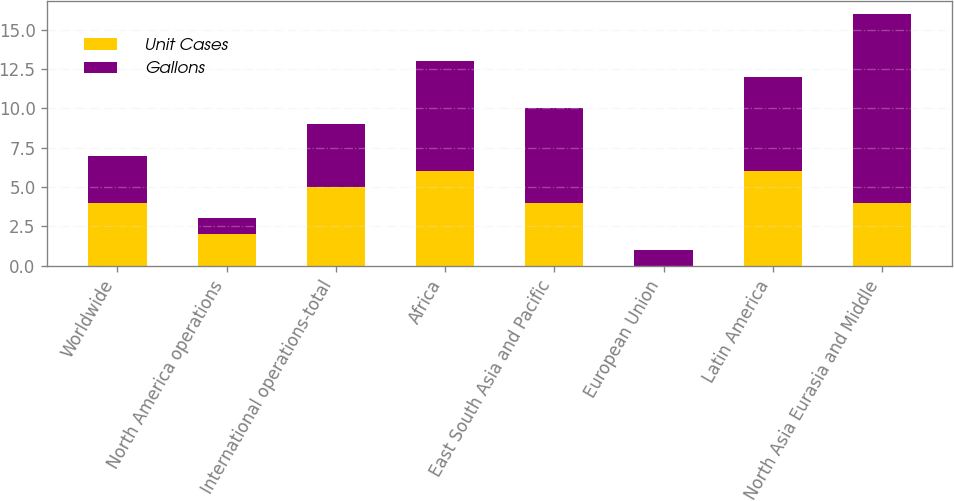Convert chart. <chart><loc_0><loc_0><loc_500><loc_500><stacked_bar_chart><ecel><fcel>Worldwide<fcel>North America operations<fcel>International operations-total<fcel>Africa<fcel>East South Asia and Pacific<fcel>European Union<fcel>Latin America<fcel>North Asia Eurasia and Middle<nl><fcel>Unit Cases<fcel>4<fcel>2<fcel>5<fcel>6<fcel>4<fcel>0<fcel>6<fcel>4<nl><fcel>Gallons<fcel>3<fcel>1<fcel>4<fcel>7<fcel>6<fcel>1<fcel>6<fcel>12<nl></chart> 